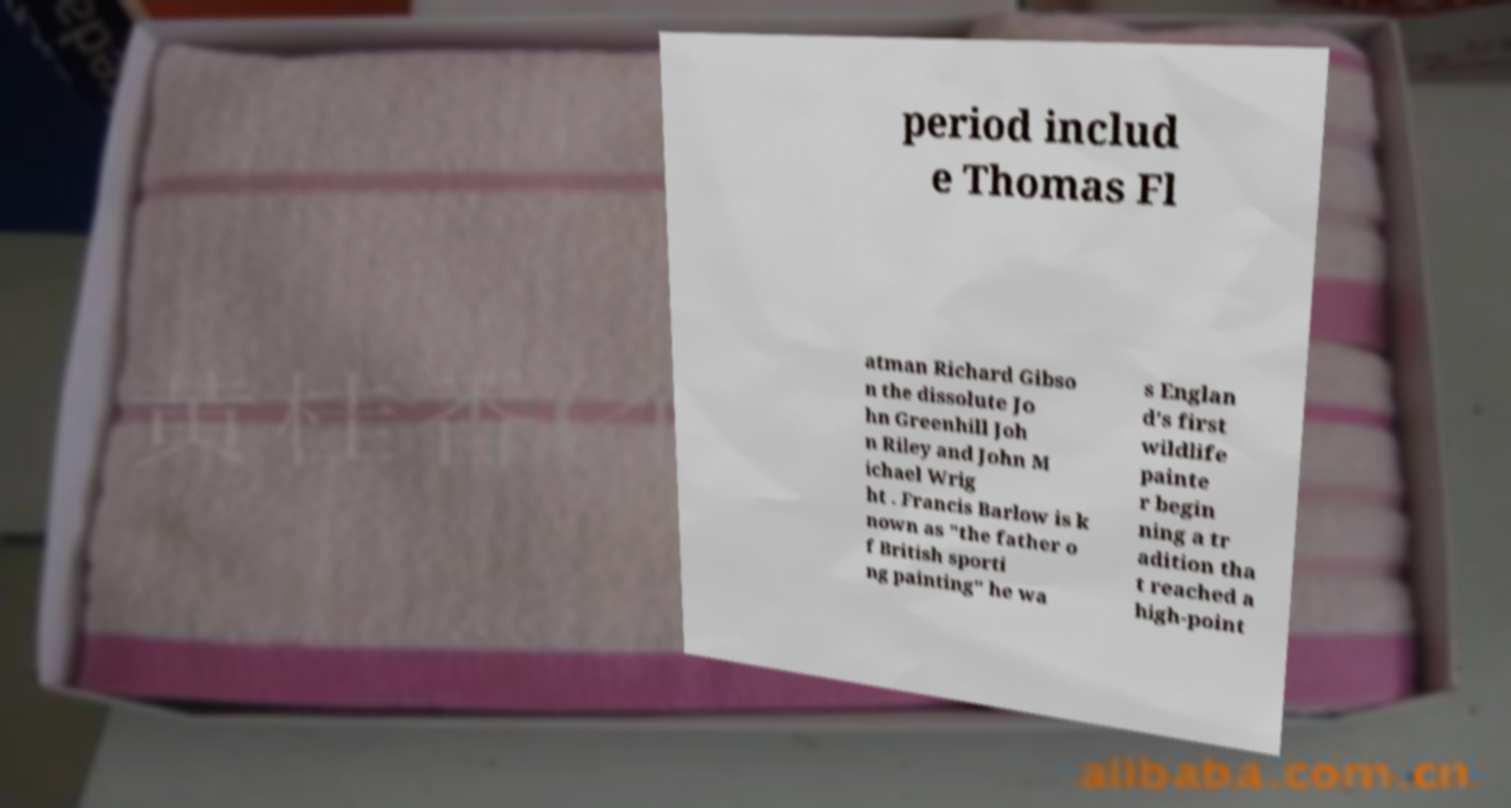Can you accurately transcribe the text from the provided image for me? period includ e Thomas Fl atman Richard Gibso n the dissolute Jo hn Greenhill Joh n Riley and John M ichael Wrig ht . Francis Barlow is k nown as "the father o f British sporti ng painting" he wa s Englan d's first wildlife painte r begin ning a tr adition tha t reached a high-point 